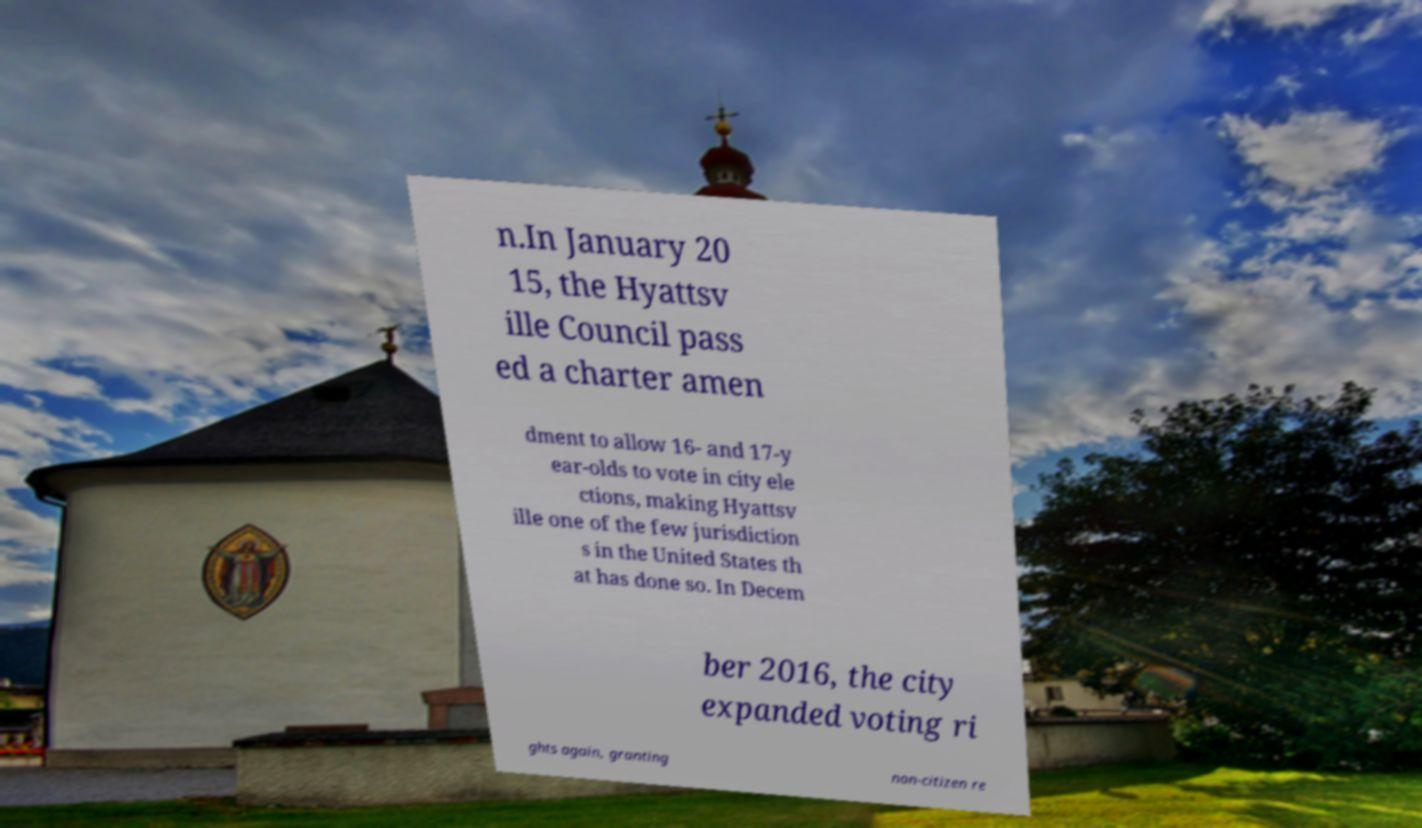What messages or text are displayed in this image? I need them in a readable, typed format. n.In January 20 15, the Hyattsv ille Council pass ed a charter amen dment to allow 16- and 17-y ear-olds to vote in city ele ctions, making Hyattsv ille one of the few jurisdiction s in the United States th at has done so. In Decem ber 2016, the city expanded voting ri ghts again, granting non-citizen re 